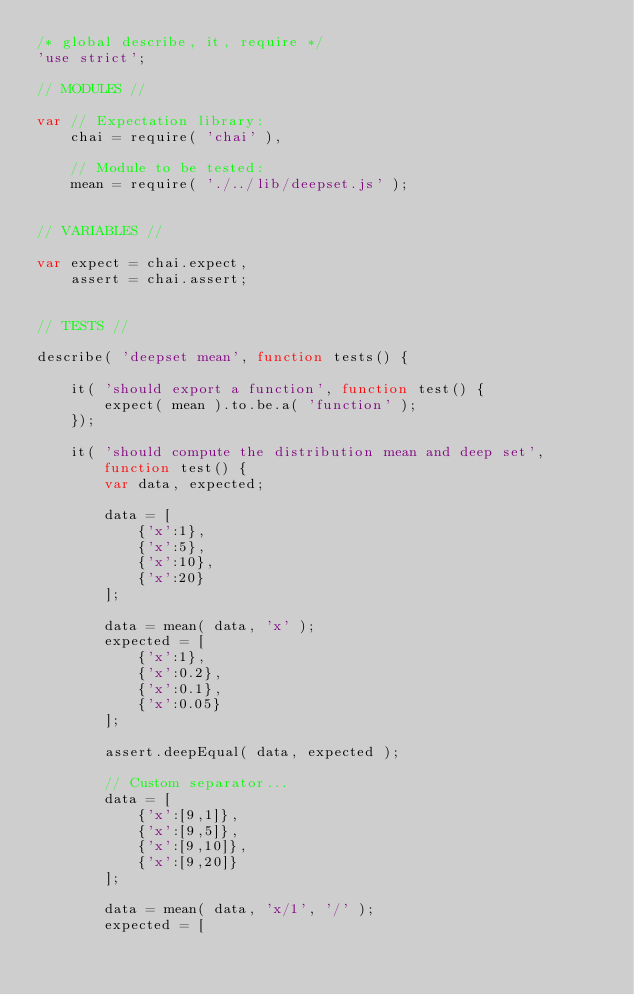Convert code to text. <code><loc_0><loc_0><loc_500><loc_500><_JavaScript_>/* global describe, it, require */
'use strict';

// MODULES //

var // Expectation library:
	chai = require( 'chai' ),

	// Module to be tested:
	mean = require( './../lib/deepset.js' );


// VARIABLES //

var expect = chai.expect,
	assert = chai.assert;


// TESTS //

describe( 'deepset mean', function tests() {

	it( 'should export a function', function test() {
		expect( mean ).to.be.a( 'function' );
	});

	it( 'should compute the distribution mean and deep set', function test() {
		var data, expected;

		data = [
			{'x':1},
			{'x':5},
			{'x':10},
			{'x':20}
		];

		data = mean( data, 'x' );
		expected = [
			{'x':1},
			{'x':0.2},
			{'x':0.1},
			{'x':0.05}
		];

		assert.deepEqual( data, expected );

		// Custom separator...
		data = [
			{'x':[9,1]},
			{'x':[9,5]},
			{'x':[9,10]},
			{'x':[9,20]}
		];

		data = mean( data, 'x/1', '/' );
		expected = [</code> 